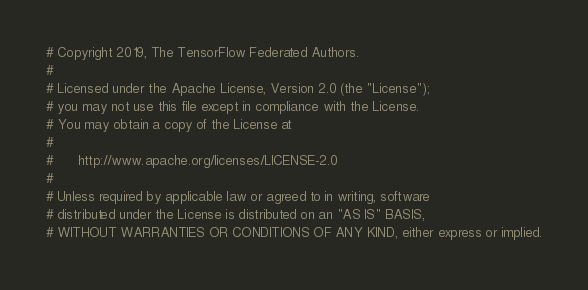<code> <loc_0><loc_0><loc_500><loc_500><_Python_># Copyright 2019, The TensorFlow Federated Authors.
#
# Licensed under the Apache License, Version 2.0 (the "License");
# you may not use this file except in compliance with the License.
# You may obtain a copy of the License at
#
#      http://www.apache.org/licenses/LICENSE-2.0
#
# Unless required by applicable law or agreed to in writing, software
# distributed under the License is distributed on an "AS IS" BASIS,
# WITHOUT WARRANTIES OR CONDITIONS OF ANY KIND, either express or implied.</code> 